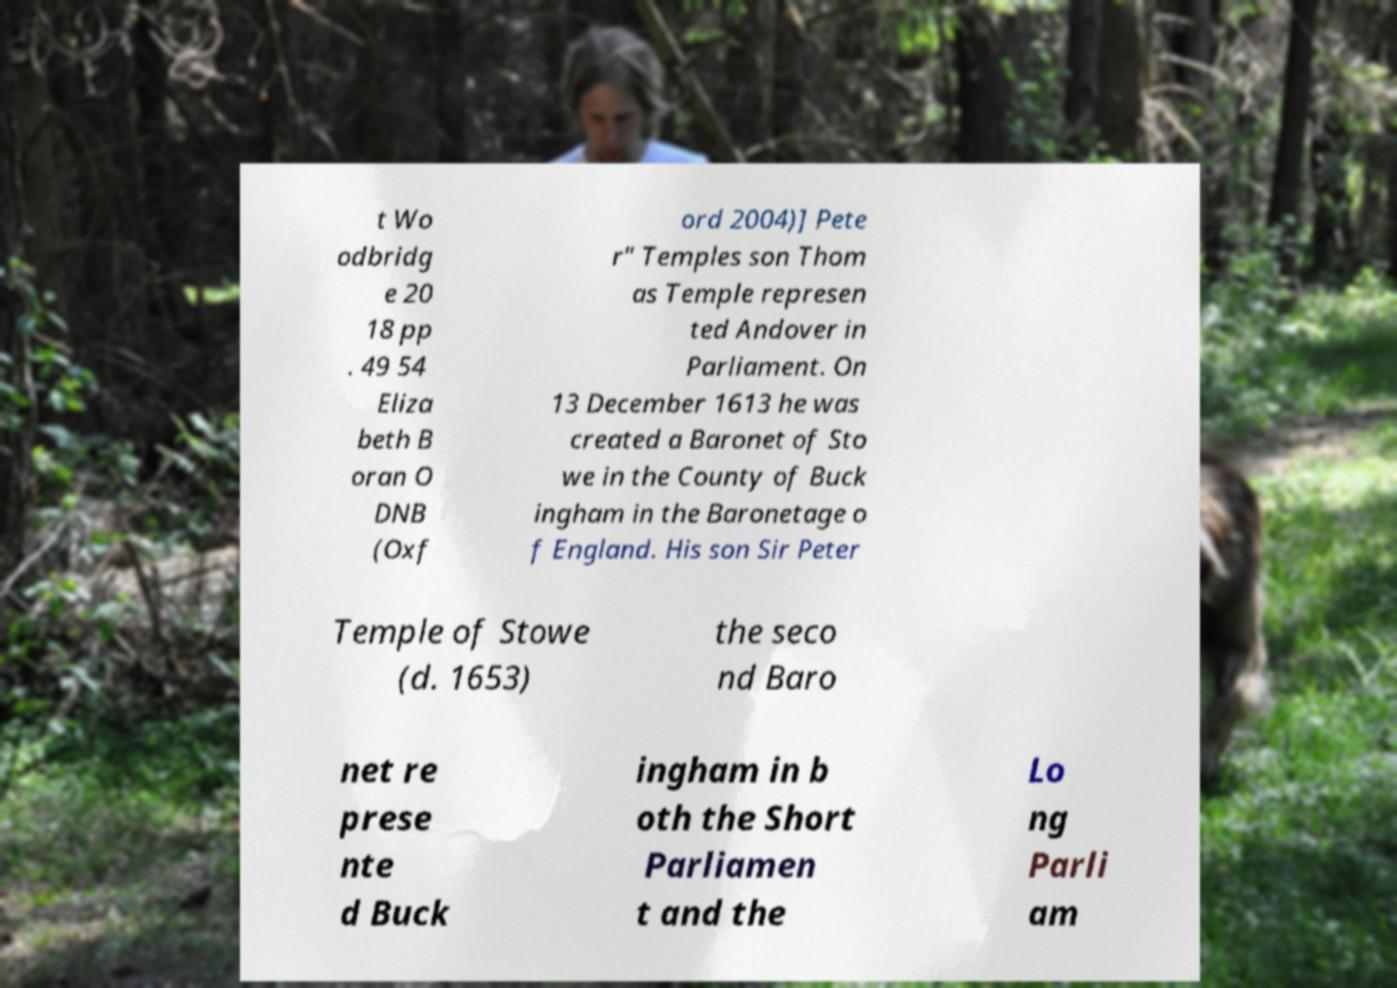Can you accurately transcribe the text from the provided image for me? t Wo odbridg e 20 18 pp . 49 54 Eliza beth B oran O DNB (Oxf ord 2004)] Pete r" Temples son Thom as Temple represen ted Andover in Parliament. On 13 December 1613 he was created a Baronet of Sto we in the County of Buck ingham in the Baronetage o f England. His son Sir Peter Temple of Stowe (d. 1653) the seco nd Baro net re prese nte d Buck ingham in b oth the Short Parliamen t and the Lo ng Parli am 